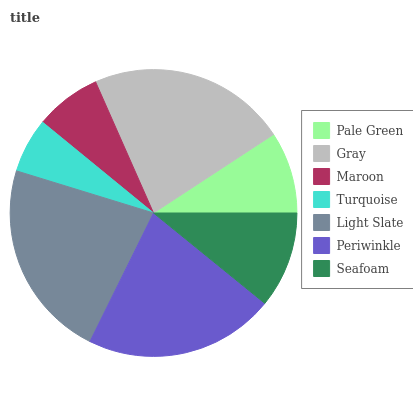Is Turquoise the minimum?
Answer yes or no. Yes. Is Light Slate the maximum?
Answer yes or no. Yes. Is Gray the minimum?
Answer yes or no. No. Is Gray the maximum?
Answer yes or no. No. Is Gray greater than Pale Green?
Answer yes or no. Yes. Is Pale Green less than Gray?
Answer yes or no. Yes. Is Pale Green greater than Gray?
Answer yes or no. No. Is Gray less than Pale Green?
Answer yes or no. No. Is Seafoam the high median?
Answer yes or no. Yes. Is Seafoam the low median?
Answer yes or no. Yes. Is Maroon the high median?
Answer yes or no. No. Is Periwinkle the low median?
Answer yes or no. No. 